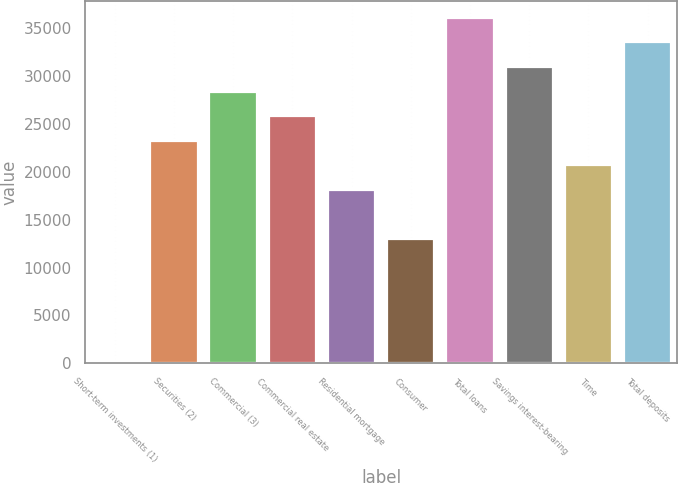Convert chart to OTSL. <chart><loc_0><loc_0><loc_500><loc_500><bar_chart><fcel>Short-term investments (1)<fcel>Securities (2)<fcel>Commercial (3)<fcel>Commercial real estate<fcel>Residential mortgage<fcel>Consumer<fcel>Total loans<fcel>Savings interest-bearing<fcel>Time<fcel>Total deposits<nl><fcel>156.1<fcel>23255<fcel>28388<fcel>25821.5<fcel>18121.9<fcel>12988.8<fcel>36087.7<fcel>30954.6<fcel>20688.4<fcel>33521.1<nl></chart> 